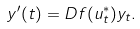Convert formula to latex. <formula><loc_0><loc_0><loc_500><loc_500>y ^ { \prime } ( t ) = D f ( u _ { t } ^ { * } ) y _ { t } .</formula> 